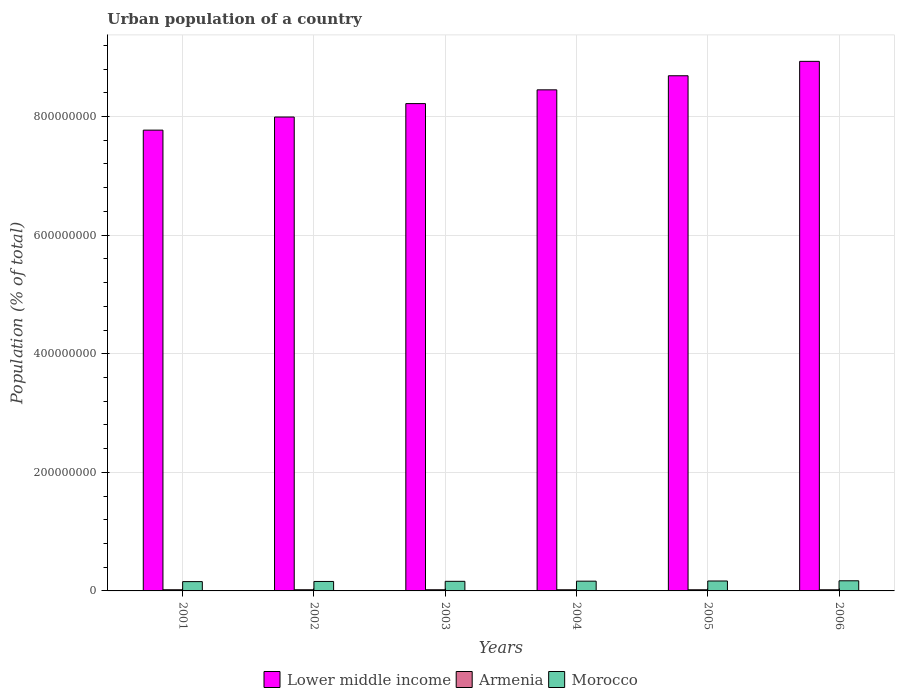How many groups of bars are there?
Give a very brief answer. 6. Are the number of bars per tick equal to the number of legend labels?
Your response must be concise. Yes. Are the number of bars on each tick of the X-axis equal?
Keep it short and to the point. Yes. How many bars are there on the 5th tick from the left?
Your answer should be compact. 3. What is the label of the 6th group of bars from the left?
Your answer should be very brief. 2006. In how many cases, is the number of bars for a given year not equal to the number of legend labels?
Provide a succinct answer. 0. What is the urban population in Lower middle income in 2004?
Make the answer very short. 8.45e+08. Across all years, what is the maximum urban population in Armenia?
Make the answer very short. 1.97e+06. Across all years, what is the minimum urban population in Morocco?
Give a very brief answer. 1.57e+07. In which year was the urban population in Morocco maximum?
Offer a terse response. 2006. In which year was the urban population in Morocco minimum?
Offer a terse response. 2001. What is the total urban population in Morocco in the graph?
Make the answer very short. 9.81e+07. What is the difference between the urban population in Morocco in 2001 and that in 2002?
Your answer should be compact. -2.50e+05. What is the difference between the urban population in Armenia in 2003 and the urban population in Lower middle income in 2006?
Provide a short and direct response. -8.91e+08. What is the average urban population in Armenia per year?
Give a very brief answer. 1.95e+06. In the year 2001, what is the difference between the urban population in Morocco and urban population in Armenia?
Your response must be concise. 1.37e+07. In how many years, is the urban population in Armenia greater than 760000000 %?
Keep it short and to the point. 0. What is the ratio of the urban population in Lower middle income in 2004 to that in 2005?
Provide a succinct answer. 0.97. What is the difference between the highest and the second highest urban population in Morocco?
Make the answer very short. 3.26e+05. What is the difference between the highest and the lowest urban population in Armenia?
Provide a succinct answer. 4.43e+04. In how many years, is the urban population in Armenia greater than the average urban population in Armenia taken over all years?
Provide a short and direct response. 3. Is the sum of the urban population in Armenia in 2001 and 2005 greater than the maximum urban population in Lower middle income across all years?
Offer a very short reply. No. What does the 1st bar from the left in 2001 represents?
Provide a short and direct response. Lower middle income. What does the 3rd bar from the right in 2001 represents?
Your response must be concise. Lower middle income. Is it the case that in every year, the sum of the urban population in Armenia and urban population in Morocco is greater than the urban population in Lower middle income?
Ensure brevity in your answer.  No. Are all the bars in the graph horizontal?
Ensure brevity in your answer.  No. How many years are there in the graph?
Give a very brief answer. 6. What is the difference between two consecutive major ticks on the Y-axis?
Provide a short and direct response. 2.00e+08. Where does the legend appear in the graph?
Offer a very short reply. Bottom center. How many legend labels are there?
Give a very brief answer. 3. What is the title of the graph?
Ensure brevity in your answer.  Urban population of a country. What is the label or title of the X-axis?
Make the answer very short. Years. What is the label or title of the Y-axis?
Provide a succinct answer. Population (% of total). What is the Population (% of total) in Lower middle income in 2001?
Offer a terse response. 7.77e+08. What is the Population (% of total) in Armenia in 2001?
Offer a terse response. 1.97e+06. What is the Population (% of total) of Morocco in 2001?
Your answer should be very brief. 1.57e+07. What is the Population (% of total) of Lower middle income in 2002?
Ensure brevity in your answer.  7.99e+08. What is the Population (% of total) in Armenia in 2002?
Make the answer very short. 1.96e+06. What is the Population (% of total) in Morocco in 2002?
Your answer should be compact. 1.59e+07. What is the Population (% of total) in Lower middle income in 2003?
Your answer should be compact. 8.22e+08. What is the Population (% of total) in Armenia in 2003?
Offer a very short reply. 1.95e+06. What is the Population (% of total) in Morocco in 2003?
Your answer should be compact. 1.62e+07. What is the Population (% of total) of Lower middle income in 2004?
Make the answer very short. 8.45e+08. What is the Population (% of total) of Armenia in 2004?
Offer a very short reply. 1.94e+06. What is the Population (% of total) of Morocco in 2004?
Keep it short and to the point. 1.64e+07. What is the Population (% of total) of Lower middle income in 2005?
Ensure brevity in your answer.  8.69e+08. What is the Population (% of total) of Armenia in 2005?
Ensure brevity in your answer.  1.94e+06. What is the Population (% of total) of Morocco in 2005?
Offer a terse response. 1.68e+07. What is the Population (% of total) in Lower middle income in 2006?
Your response must be concise. 8.93e+08. What is the Population (% of total) of Armenia in 2006?
Give a very brief answer. 1.93e+06. What is the Population (% of total) in Morocco in 2006?
Offer a very short reply. 1.71e+07. Across all years, what is the maximum Population (% of total) in Lower middle income?
Ensure brevity in your answer.  8.93e+08. Across all years, what is the maximum Population (% of total) of Armenia?
Your answer should be compact. 1.97e+06. Across all years, what is the maximum Population (% of total) in Morocco?
Your response must be concise. 1.71e+07. Across all years, what is the minimum Population (% of total) of Lower middle income?
Your answer should be very brief. 7.77e+08. Across all years, what is the minimum Population (% of total) in Armenia?
Keep it short and to the point. 1.93e+06. Across all years, what is the minimum Population (% of total) in Morocco?
Provide a short and direct response. 1.57e+07. What is the total Population (% of total) of Lower middle income in the graph?
Give a very brief answer. 5.01e+09. What is the total Population (% of total) of Armenia in the graph?
Offer a terse response. 1.17e+07. What is the total Population (% of total) of Morocco in the graph?
Offer a very short reply. 9.81e+07. What is the difference between the Population (% of total) of Lower middle income in 2001 and that in 2002?
Provide a succinct answer. -2.21e+07. What is the difference between the Population (% of total) of Armenia in 2001 and that in 2002?
Give a very brief answer. 1.13e+04. What is the difference between the Population (% of total) of Morocco in 2001 and that in 2002?
Offer a very short reply. -2.50e+05. What is the difference between the Population (% of total) in Lower middle income in 2001 and that in 2003?
Offer a very short reply. -4.47e+07. What is the difference between the Population (% of total) of Armenia in 2001 and that in 2003?
Provide a short and direct response. 1.93e+04. What is the difference between the Population (% of total) in Morocco in 2001 and that in 2003?
Ensure brevity in your answer.  -4.97e+05. What is the difference between the Population (% of total) in Lower middle income in 2001 and that in 2004?
Ensure brevity in your answer.  -6.79e+07. What is the difference between the Population (% of total) of Armenia in 2001 and that in 2004?
Provide a short and direct response. 2.70e+04. What is the difference between the Population (% of total) of Morocco in 2001 and that in 2004?
Your answer should be very brief. -7.47e+05. What is the difference between the Population (% of total) in Lower middle income in 2001 and that in 2005?
Your answer should be compact. -9.17e+07. What is the difference between the Population (% of total) in Armenia in 2001 and that in 2005?
Keep it short and to the point. 3.51e+04. What is the difference between the Population (% of total) in Morocco in 2001 and that in 2005?
Keep it short and to the point. -1.05e+06. What is the difference between the Population (% of total) of Lower middle income in 2001 and that in 2006?
Your answer should be very brief. -1.16e+08. What is the difference between the Population (% of total) of Armenia in 2001 and that in 2006?
Provide a short and direct response. 4.43e+04. What is the difference between the Population (% of total) of Morocco in 2001 and that in 2006?
Your answer should be compact. -1.38e+06. What is the difference between the Population (% of total) in Lower middle income in 2002 and that in 2003?
Give a very brief answer. -2.27e+07. What is the difference between the Population (% of total) of Armenia in 2002 and that in 2003?
Your response must be concise. 7963. What is the difference between the Population (% of total) in Morocco in 2002 and that in 2003?
Offer a very short reply. -2.47e+05. What is the difference between the Population (% of total) in Lower middle income in 2002 and that in 2004?
Provide a succinct answer. -4.59e+07. What is the difference between the Population (% of total) of Armenia in 2002 and that in 2004?
Ensure brevity in your answer.  1.57e+04. What is the difference between the Population (% of total) of Morocco in 2002 and that in 2004?
Offer a terse response. -4.98e+05. What is the difference between the Population (% of total) in Lower middle income in 2002 and that in 2005?
Provide a succinct answer. -6.96e+07. What is the difference between the Population (% of total) of Armenia in 2002 and that in 2005?
Keep it short and to the point. 2.38e+04. What is the difference between the Population (% of total) in Morocco in 2002 and that in 2005?
Your answer should be compact. -8.04e+05. What is the difference between the Population (% of total) in Lower middle income in 2002 and that in 2006?
Offer a very short reply. -9.39e+07. What is the difference between the Population (% of total) in Armenia in 2002 and that in 2006?
Your answer should be very brief. 3.30e+04. What is the difference between the Population (% of total) of Morocco in 2002 and that in 2006?
Give a very brief answer. -1.13e+06. What is the difference between the Population (% of total) of Lower middle income in 2003 and that in 2004?
Your response must be concise. -2.32e+07. What is the difference between the Population (% of total) in Armenia in 2003 and that in 2004?
Keep it short and to the point. 7705. What is the difference between the Population (% of total) in Morocco in 2003 and that in 2004?
Your answer should be very brief. -2.51e+05. What is the difference between the Population (% of total) of Lower middle income in 2003 and that in 2005?
Keep it short and to the point. -4.70e+07. What is the difference between the Population (% of total) in Armenia in 2003 and that in 2005?
Offer a very short reply. 1.58e+04. What is the difference between the Population (% of total) in Morocco in 2003 and that in 2005?
Offer a terse response. -5.57e+05. What is the difference between the Population (% of total) of Lower middle income in 2003 and that in 2006?
Offer a terse response. -7.12e+07. What is the difference between the Population (% of total) of Armenia in 2003 and that in 2006?
Your response must be concise. 2.50e+04. What is the difference between the Population (% of total) of Morocco in 2003 and that in 2006?
Provide a short and direct response. -8.83e+05. What is the difference between the Population (% of total) in Lower middle income in 2004 and that in 2005?
Ensure brevity in your answer.  -2.38e+07. What is the difference between the Population (% of total) in Armenia in 2004 and that in 2005?
Ensure brevity in your answer.  8101. What is the difference between the Population (% of total) of Morocco in 2004 and that in 2005?
Make the answer very short. -3.06e+05. What is the difference between the Population (% of total) in Lower middle income in 2004 and that in 2006?
Offer a terse response. -4.80e+07. What is the difference between the Population (% of total) in Armenia in 2004 and that in 2006?
Offer a terse response. 1.73e+04. What is the difference between the Population (% of total) in Morocco in 2004 and that in 2006?
Your answer should be very brief. -6.33e+05. What is the difference between the Population (% of total) of Lower middle income in 2005 and that in 2006?
Ensure brevity in your answer.  -2.43e+07. What is the difference between the Population (% of total) in Armenia in 2005 and that in 2006?
Make the answer very short. 9208. What is the difference between the Population (% of total) in Morocco in 2005 and that in 2006?
Your answer should be compact. -3.26e+05. What is the difference between the Population (% of total) of Lower middle income in 2001 and the Population (% of total) of Armenia in 2002?
Offer a very short reply. 7.75e+08. What is the difference between the Population (% of total) in Lower middle income in 2001 and the Population (% of total) in Morocco in 2002?
Your answer should be compact. 7.61e+08. What is the difference between the Population (% of total) of Armenia in 2001 and the Population (% of total) of Morocco in 2002?
Ensure brevity in your answer.  -1.40e+07. What is the difference between the Population (% of total) in Lower middle income in 2001 and the Population (% of total) in Armenia in 2003?
Make the answer very short. 7.75e+08. What is the difference between the Population (% of total) in Lower middle income in 2001 and the Population (% of total) in Morocco in 2003?
Provide a short and direct response. 7.61e+08. What is the difference between the Population (% of total) in Armenia in 2001 and the Population (% of total) in Morocco in 2003?
Provide a succinct answer. -1.42e+07. What is the difference between the Population (% of total) of Lower middle income in 2001 and the Population (% of total) of Armenia in 2004?
Offer a very short reply. 7.75e+08. What is the difference between the Population (% of total) in Lower middle income in 2001 and the Population (% of total) in Morocco in 2004?
Keep it short and to the point. 7.61e+08. What is the difference between the Population (% of total) of Armenia in 2001 and the Population (% of total) of Morocco in 2004?
Ensure brevity in your answer.  -1.45e+07. What is the difference between the Population (% of total) in Lower middle income in 2001 and the Population (% of total) in Armenia in 2005?
Keep it short and to the point. 7.75e+08. What is the difference between the Population (% of total) in Lower middle income in 2001 and the Population (% of total) in Morocco in 2005?
Make the answer very short. 7.60e+08. What is the difference between the Population (% of total) in Armenia in 2001 and the Population (% of total) in Morocco in 2005?
Make the answer very short. -1.48e+07. What is the difference between the Population (% of total) of Lower middle income in 2001 and the Population (% of total) of Armenia in 2006?
Ensure brevity in your answer.  7.75e+08. What is the difference between the Population (% of total) in Lower middle income in 2001 and the Population (% of total) in Morocco in 2006?
Your response must be concise. 7.60e+08. What is the difference between the Population (% of total) of Armenia in 2001 and the Population (% of total) of Morocco in 2006?
Your response must be concise. -1.51e+07. What is the difference between the Population (% of total) of Lower middle income in 2002 and the Population (% of total) of Armenia in 2003?
Ensure brevity in your answer.  7.97e+08. What is the difference between the Population (% of total) of Lower middle income in 2002 and the Population (% of total) of Morocco in 2003?
Offer a very short reply. 7.83e+08. What is the difference between the Population (% of total) of Armenia in 2002 and the Population (% of total) of Morocco in 2003?
Provide a short and direct response. -1.42e+07. What is the difference between the Population (% of total) in Lower middle income in 2002 and the Population (% of total) in Armenia in 2004?
Give a very brief answer. 7.97e+08. What is the difference between the Population (% of total) in Lower middle income in 2002 and the Population (% of total) in Morocco in 2004?
Ensure brevity in your answer.  7.83e+08. What is the difference between the Population (% of total) in Armenia in 2002 and the Population (% of total) in Morocco in 2004?
Your response must be concise. -1.45e+07. What is the difference between the Population (% of total) of Lower middle income in 2002 and the Population (% of total) of Armenia in 2005?
Give a very brief answer. 7.97e+08. What is the difference between the Population (% of total) of Lower middle income in 2002 and the Population (% of total) of Morocco in 2005?
Your answer should be compact. 7.82e+08. What is the difference between the Population (% of total) in Armenia in 2002 and the Population (% of total) in Morocco in 2005?
Your response must be concise. -1.48e+07. What is the difference between the Population (% of total) of Lower middle income in 2002 and the Population (% of total) of Armenia in 2006?
Your answer should be compact. 7.97e+08. What is the difference between the Population (% of total) of Lower middle income in 2002 and the Population (% of total) of Morocco in 2006?
Offer a very short reply. 7.82e+08. What is the difference between the Population (% of total) in Armenia in 2002 and the Population (% of total) in Morocco in 2006?
Your answer should be very brief. -1.51e+07. What is the difference between the Population (% of total) in Lower middle income in 2003 and the Population (% of total) in Armenia in 2004?
Provide a succinct answer. 8.20e+08. What is the difference between the Population (% of total) of Lower middle income in 2003 and the Population (% of total) of Morocco in 2004?
Your answer should be very brief. 8.05e+08. What is the difference between the Population (% of total) of Armenia in 2003 and the Population (% of total) of Morocco in 2004?
Provide a short and direct response. -1.45e+07. What is the difference between the Population (% of total) in Lower middle income in 2003 and the Population (% of total) in Armenia in 2005?
Ensure brevity in your answer.  8.20e+08. What is the difference between the Population (% of total) of Lower middle income in 2003 and the Population (% of total) of Morocco in 2005?
Give a very brief answer. 8.05e+08. What is the difference between the Population (% of total) of Armenia in 2003 and the Population (% of total) of Morocco in 2005?
Keep it short and to the point. -1.48e+07. What is the difference between the Population (% of total) in Lower middle income in 2003 and the Population (% of total) in Armenia in 2006?
Give a very brief answer. 8.20e+08. What is the difference between the Population (% of total) in Lower middle income in 2003 and the Population (% of total) in Morocco in 2006?
Your answer should be very brief. 8.05e+08. What is the difference between the Population (% of total) in Armenia in 2003 and the Population (% of total) in Morocco in 2006?
Offer a terse response. -1.51e+07. What is the difference between the Population (% of total) of Lower middle income in 2004 and the Population (% of total) of Armenia in 2005?
Provide a succinct answer. 8.43e+08. What is the difference between the Population (% of total) in Lower middle income in 2004 and the Population (% of total) in Morocco in 2005?
Provide a succinct answer. 8.28e+08. What is the difference between the Population (% of total) in Armenia in 2004 and the Population (% of total) in Morocco in 2005?
Provide a succinct answer. -1.48e+07. What is the difference between the Population (% of total) of Lower middle income in 2004 and the Population (% of total) of Armenia in 2006?
Provide a succinct answer. 8.43e+08. What is the difference between the Population (% of total) of Lower middle income in 2004 and the Population (% of total) of Morocco in 2006?
Make the answer very short. 8.28e+08. What is the difference between the Population (% of total) of Armenia in 2004 and the Population (% of total) of Morocco in 2006?
Offer a terse response. -1.51e+07. What is the difference between the Population (% of total) of Lower middle income in 2005 and the Population (% of total) of Armenia in 2006?
Your response must be concise. 8.67e+08. What is the difference between the Population (% of total) of Lower middle income in 2005 and the Population (% of total) of Morocco in 2006?
Provide a short and direct response. 8.52e+08. What is the difference between the Population (% of total) in Armenia in 2005 and the Population (% of total) in Morocco in 2006?
Your answer should be very brief. -1.51e+07. What is the average Population (% of total) in Lower middle income per year?
Ensure brevity in your answer.  8.34e+08. What is the average Population (% of total) of Armenia per year?
Provide a short and direct response. 1.95e+06. What is the average Population (% of total) of Morocco per year?
Keep it short and to the point. 1.64e+07. In the year 2001, what is the difference between the Population (% of total) in Lower middle income and Population (% of total) in Armenia?
Provide a short and direct response. 7.75e+08. In the year 2001, what is the difference between the Population (% of total) in Lower middle income and Population (% of total) in Morocco?
Provide a succinct answer. 7.61e+08. In the year 2001, what is the difference between the Population (% of total) in Armenia and Population (% of total) in Morocco?
Your answer should be compact. -1.37e+07. In the year 2002, what is the difference between the Population (% of total) in Lower middle income and Population (% of total) in Armenia?
Give a very brief answer. 7.97e+08. In the year 2002, what is the difference between the Population (% of total) in Lower middle income and Population (% of total) in Morocco?
Provide a short and direct response. 7.83e+08. In the year 2002, what is the difference between the Population (% of total) in Armenia and Population (% of total) in Morocco?
Your response must be concise. -1.40e+07. In the year 2003, what is the difference between the Population (% of total) in Lower middle income and Population (% of total) in Armenia?
Make the answer very short. 8.20e+08. In the year 2003, what is the difference between the Population (% of total) in Lower middle income and Population (% of total) in Morocco?
Give a very brief answer. 8.06e+08. In the year 2003, what is the difference between the Population (% of total) of Armenia and Population (% of total) of Morocco?
Provide a short and direct response. -1.42e+07. In the year 2004, what is the difference between the Population (% of total) in Lower middle income and Population (% of total) in Armenia?
Give a very brief answer. 8.43e+08. In the year 2004, what is the difference between the Population (% of total) in Lower middle income and Population (% of total) in Morocco?
Your answer should be compact. 8.29e+08. In the year 2004, what is the difference between the Population (% of total) in Armenia and Population (% of total) in Morocco?
Your answer should be compact. -1.45e+07. In the year 2005, what is the difference between the Population (% of total) of Lower middle income and Population (% of total) of Armenia?
Provide a succinct answer. 8.67e+08. In the year 2005, what is the difference between the Population (% of total) in Lower middle income and Population (% of total) in Morocco?
Your answer should be very brief. 8.52e+08. In the year 2005, what is the difference between the Population (% of total) in Armenia and Population (% of total) in Morocco?
Your answer should be very brief. -1.48e+07. In the year 2006, what is the difference between the Population (% of total) in Lower middle income and Population (% of total) in Armenia?
Your response must be concise. 8.91e+08. In the year 2006, what is the difference between the Population (% of total) in Lower middle income and Population (% of total) in Morocco?
Your answer should be very brief. 8.76e+08. In the year 2006, what is the difference between the Population (% of total) in Armenia and Population (% of total) in Morocco?
Your answer should be compact. -1.52e+07. What is the ratio of the Population (% of total) in Lower middle income in 2001 to that in 2002?
Offer a very short reply. 0.97. What is the ratio of the Population (% of total) in Morocco in 2001 to that in 2002?
Give a very brief answer. 0.98. What is the ratio of the Population (% of total) in Lower middle income in 2001 to that in 2003?
Offer a very short reply. 0.95. What is the ratio of the Population (% of total) of Armenia in 2001 to that in 2003?
Ensure brevity in your answer.  1.01. What is the ratio of the Population (% of total) of Morocco in 2001 to that in 2003?
Make the answer very short. 0.97. What is the ratio of the Population (% of total) in Lower middle income in 2001 to that in 2004?
Provide a short and direct response. 0.92. What is the ratio of the Population (% of total) in Armenia in 2001 to that in 2004?
Offer a very short reply. 1.01. What is the ratio of the Population (% of total) in Morocco in 2001 to that in 2004?
Your answer should be compact. 0.95. What is the ratio of the Population (% of total) of Lower middle income in 2001 to that in 2005?
Make the answer very short. 0.89. What is the ratio of the Population (% of total) in Armenia in 2001 to that in 2005?
Your response must be concise. 1.02. What is the ratio of the Population (% of total) in Morocco in 2001 to that in 2005?
Keep it short and to the point. 0.94. What is the ratio of the Population (% of total) of Lower middle income in 2001 to that in 2006?
Keep it short and to the point. 0.87. What is the ratio of the Population (% of total) of Armenia in 2001 to that in 2006?
Offer a very short reply. 1.02. What is the ratio of the Population (% of total) of Morocco in 2001 to that in 2006?
Provide a succinct answer. 0.92. What is the ratio of the Population (% of total) of Lower middle income in 2002 to that in 2003?
Make the answer very short. 0.97. What is the ratio of the Population (% of total) in Morocco in 2002 to that in 2003?
Provide a short and direct response. 0.98. What is the ratio of the Population (% of total) of Lower middle income in 2002 to that in 2004?
Your answer should be compact. 0.95. What is the ratio of the Population (% of total) in Armenia in 2002 to that in 2004?
Your answer should be compact. 1.01. What is the ratio of the Population (% of total) in Morocco in 2002 to that in 2004?
Your answer should be very brief. 0.97. What is the ratio of the Population (% of total) in Lower middle income in 2002 to that in 2005?
Ensure brevity in your answer.  0.92. What is the ratio of the Population (% of total) of Armenia in 2002 to that in 2005?
Ensure brevity in your answer.  1.01. What is the ratio of the Population (% of total) of Morocco in 2002 to that in 2005?
Your answer should be compact. 0.95. What is the ratio of the Population (% of total) of Lower middle income in 2002 to that in 2006?
Give a very brief answer. 0.89. What is the ratio of the Population (% of total) of Armenia in 2002 to that in 2006?
Offer a terse response. 1.02. What is the ratio of the Population (% of total) in Morocco in 2002 to that in 2006?
Your response must be concise. 0.93. What is the ratio of the Population (% of total) of Lower middle income in 2003 to that in 2004?
Offer a terse response. 0.97. What is the ratio of the Population (% of total) in Armenia in 2003 to that in 2004?
Provide a short and direct response. 1. What is the ratio of the Population (% of total) of Morocco in 2003 to that in 2004?
Your response must be concise. 0.98. What is the ratio of the Population (% of total) of Lower middle income in 2003 to that in 2005?
Provide a short and direct response. 0.95. What is the ratio of the Population (% of total) of Armenia in 2003 to that in 2005?
Give a very brief answer. 1.01. What is the ratio of the Population (% of total) in Morocco in 2003 to that in 2005?
Make the answer very short. 0.97. What is the ratio of the Population (% of total) in Lower middle income in 2003 to that in 2006?
Your response must be concise. 0.92. What is the ratio of the Population (% of total) in Morocco in 2003 to that in 2006?
Provide a short and direct response. 0.95. What is the ratio of the Population (% of total) of Lower middle income in 2004 to that in 2005?
Offer a terse response. 0.97. What is the ratio of the Population (% of total) in Morocco in 2004 to that in 2005?
Offer a very short reply. 0.98. What is the ratio of the Population (% of total) of Lower middle income in 2004 to that in 2006?
Keep it short and to the point. 0.95. What is the ratio of the Population (% of total) of Armenia in 2004 to that in 2006?
Give a very brief answer. 1.01. What is the ratio of the Population (% of total) of Morocco in 2004 to that in 2006?
Your answer should be very brief. 0.96. What is the ratio of the Population (% of total) in Lower middle income in 2005 to that in 2006?
Your response must be concise. 0.97. What is the ratio of the Population (% of total) in Morocco in 2005 to that in 2006?
Ensure brevity in your answer.  0.98. What is the difference between the highest and the second highest Population (% of total) in Lower middle income?
Give a very brief answer. 2.43e+07. What is the difference between the highest and the second highest Population (% of total) in Armenia?
Provide a short and direct response. 1.13e+04. What is the difference between the highest and the second highest Population (% of total) of Morocco?
Your answer should be very brief. 3.26e+05. What is the difference between the highest and the lowest Population (% of total) in Lower middle income?
Provide a short and direct response. 1.16e+08. What is the difference between the highest and the lowest Population (% of total) of Armenia?
Keep it short and to the point. 4.43e+04. What is the difference between the highest and the lowest Population (% of total) of Morocco?
Make the answer very short. 1.38e+06. 